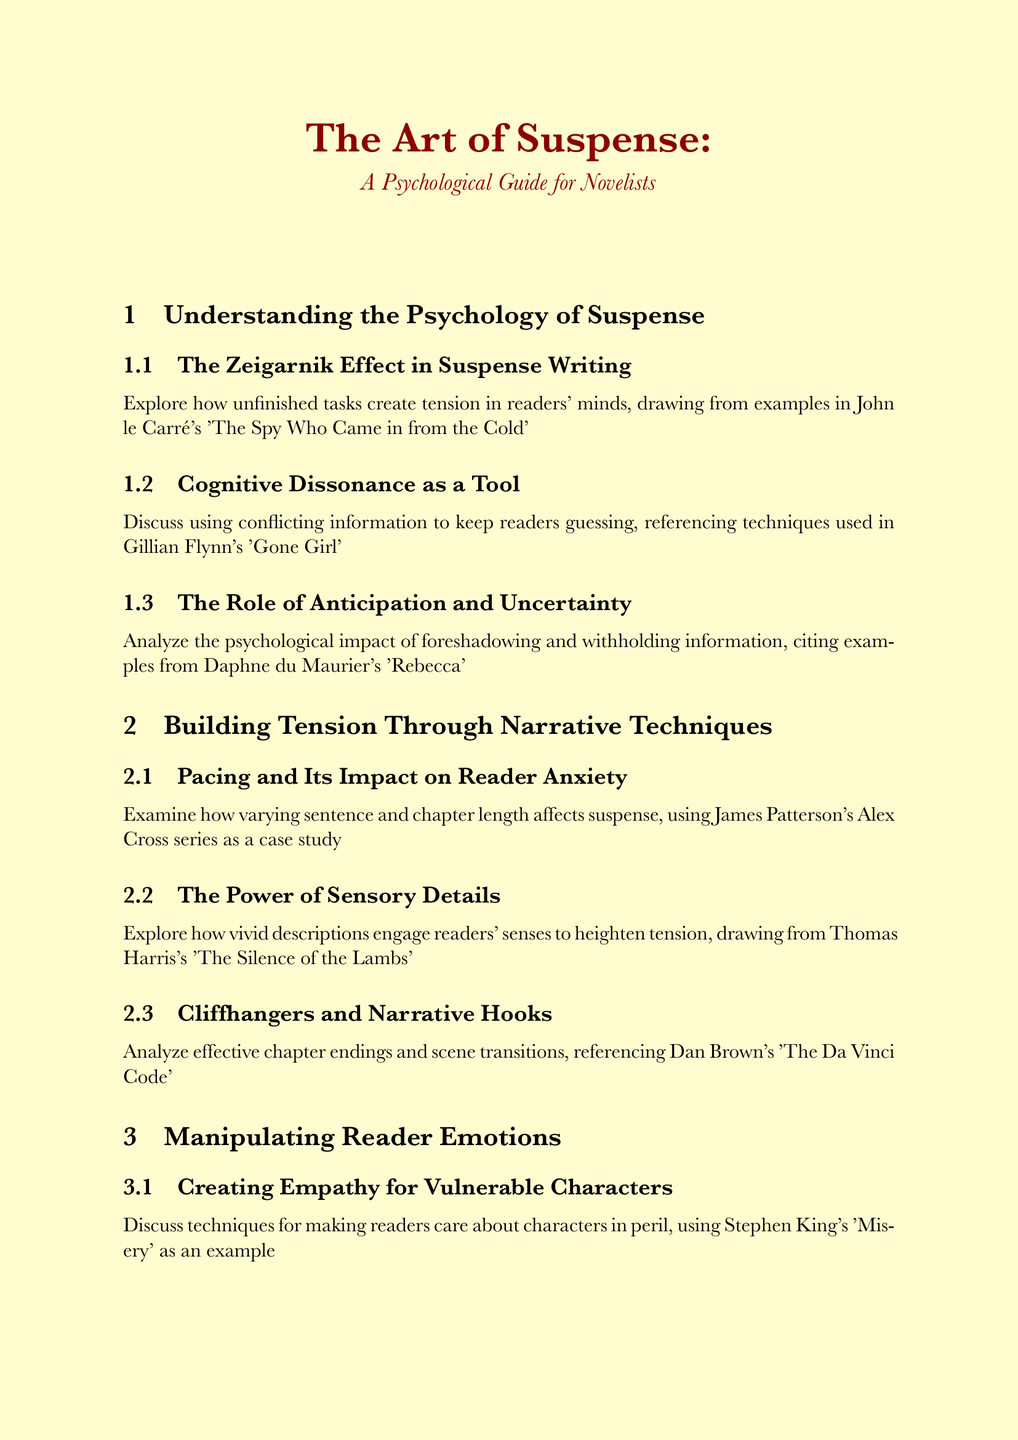What is the title of the manual? The title of the manual is prominently displayed at the beginning, stating the overarching theme of the content.
Answer: The Art of Suspense: A Psychological Guide for Novelists Who is cited in the section on the Zeigarnik Effect? The section on the Zeigarnik Effect references specific works to illustrate the concept, highlighting author contributions.
Answer: John le Carré What literary work is referenced for cognitive dissonance? The document mentions specific examples that illustrate the use of cognitive dissonance, helping to connect the theory to literature.
Answer: Gone Girl Which series is used as a case study for pacing? The document provides a case study to shed light on a specific technique, mentioning a well-known series for context.
Answer: Alex Cross series What psychological model is suggested for character development? The document refers to established psychological models as a foundation for character creation, reflecting a methodical approach.
Answer: Big Five Personality Traits Whose characters are referenced for creating empathy? This question focuses on identifying a specific author whose work demonstrates a relevant technique for engaging reader emotions.
Answer: Stephen King's Which author is associated with the thematic discussion on balancing hope and despair? The document links a specific work to an established emotional technique, showcasing its relevance in suspense writing.
Answer: Stieg Larsson's Millennium series What example is used for studying the psychology of villainy? The document identifies notable literary characters to analyze motivations, enriching the discussion on antagonist development.
Answer: Hannibal Lecter What techniques are recommended for maintaining authenticity in settings? The document posits methods for grounding narratives, ensuring relatability and plausibility in storytelling.
Answer: Techniques for grounding fantastical elements in reality Who is mentioned regarding ethical considerations in using real-world inspirations? This highlights an individual known for navigating real-life narratives in fiction, underscoring the document's emphasis on ethics.
Answer: Jason Matthews 